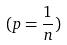Convert formula to latex. <formula><loc_0><loc_0><loc_500><loc_500>( p = \frac { 1 } { n } )</formula> 